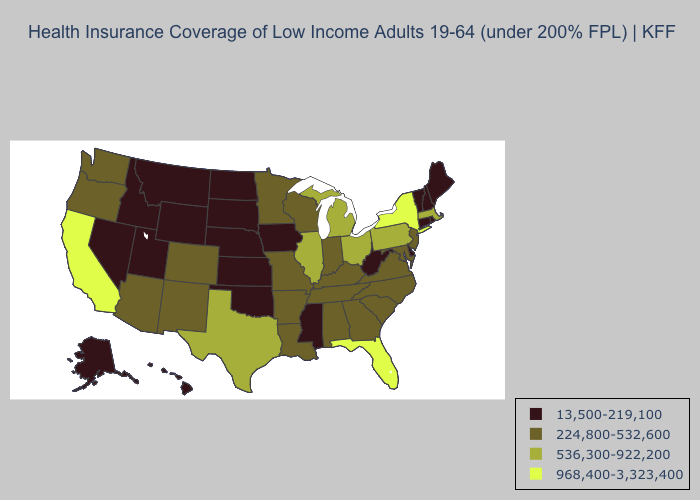Name the states that have a value in the range 536,300-922,200?
Concise answer only. Illinois, Massachusetts, Michigan, Ohio, Pennsylvania, Texas. Which states have the highest value in the USA?
Be succinct. California, Florida, New York. What is the value of Tennessee?
Quick response, please. 224,800-532,600. Name the states that have a value in the range 968,400-3,323,400?
Give a very brief answer. California, Florida, New York. What is the lowest value in the MidWest?
Give a very brief answer. 13,500-219,100. Name the states that have a value in the range 224,800-532,600?
Answer briefly. Alabama, Arizona, Arkansas, Colorado, Georgia, Indiana, Kentucky, Louisiana, Maryland, Minnesota, Missouri, New Jersey, New Mexico, North Carolina, Oregon, South Carolina, Tennessee, Virginia, Washington, Wisconsin. What is the value of West Virginia?
Give a very brief answer. 13,500-219,100. What is the value of Florida?
Keep it brief. 968,400-3,323,400. What is the value of Indiana?
Keep it brief. 224,800-532,600. Name the states that have a value in the range 536,300-922,200?
Keep it brief. Illinois, Massachusetts, Michigan, Ohio, Pennsylvania, Texas. Does the first symbol in the legend represent the smallest category?
Quick response, please. Yes. Is the legend a continuous bar?
Keep it brief. No. Does Indiana have the lowest value in the USA?
Write a very short answer. No. What is the value of Rhode Island?
Give a very brief answer. 13,500-219,100. 